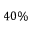Convert formula to latex. <formula><loc_0><loc_0><loc_500><loc_500>4 0 \%</formula> 